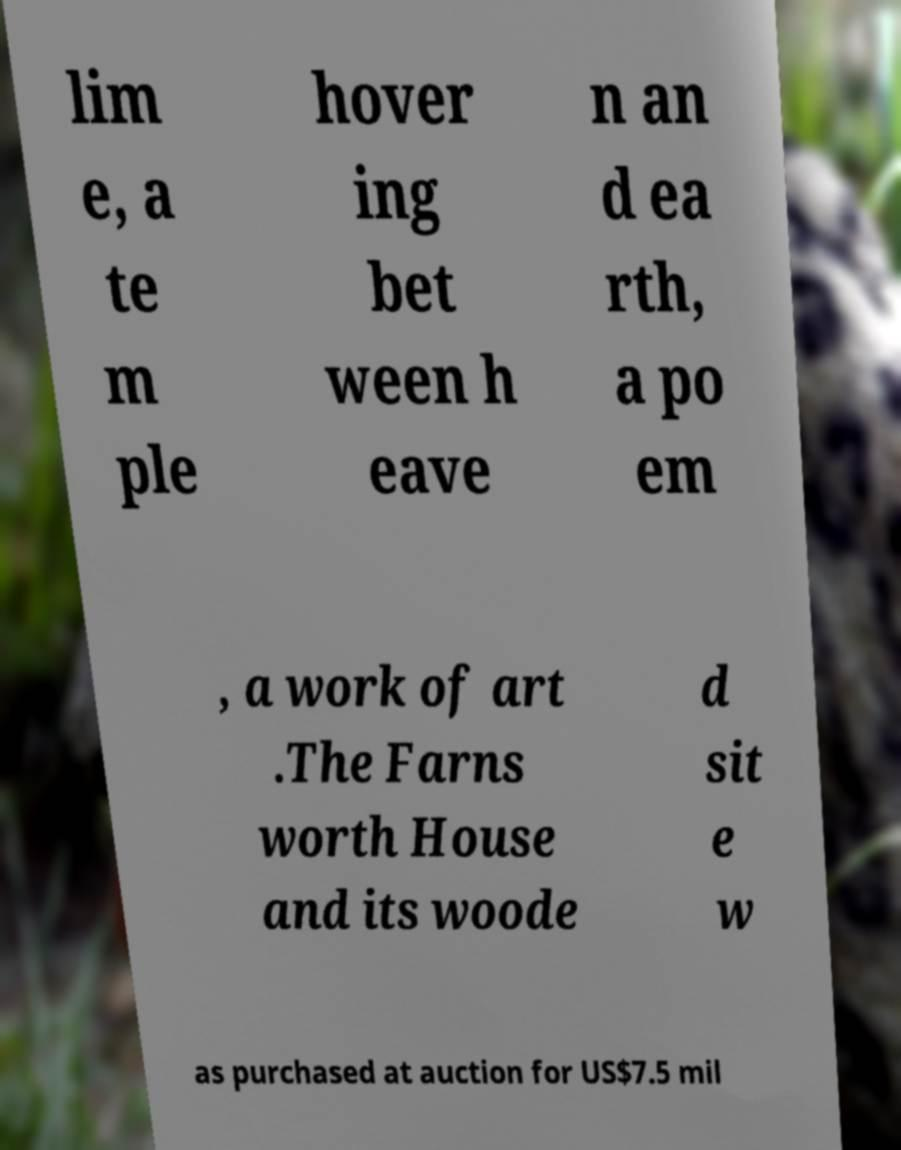I need the written content from this picture converted into text. Can you do that? lim e, a te m ple hover ing bet ween h eave n an d ea rth, a po em , a work of art .The Farns worth House and its woode d sit e w as purchased at auction for US$7.5 mil 